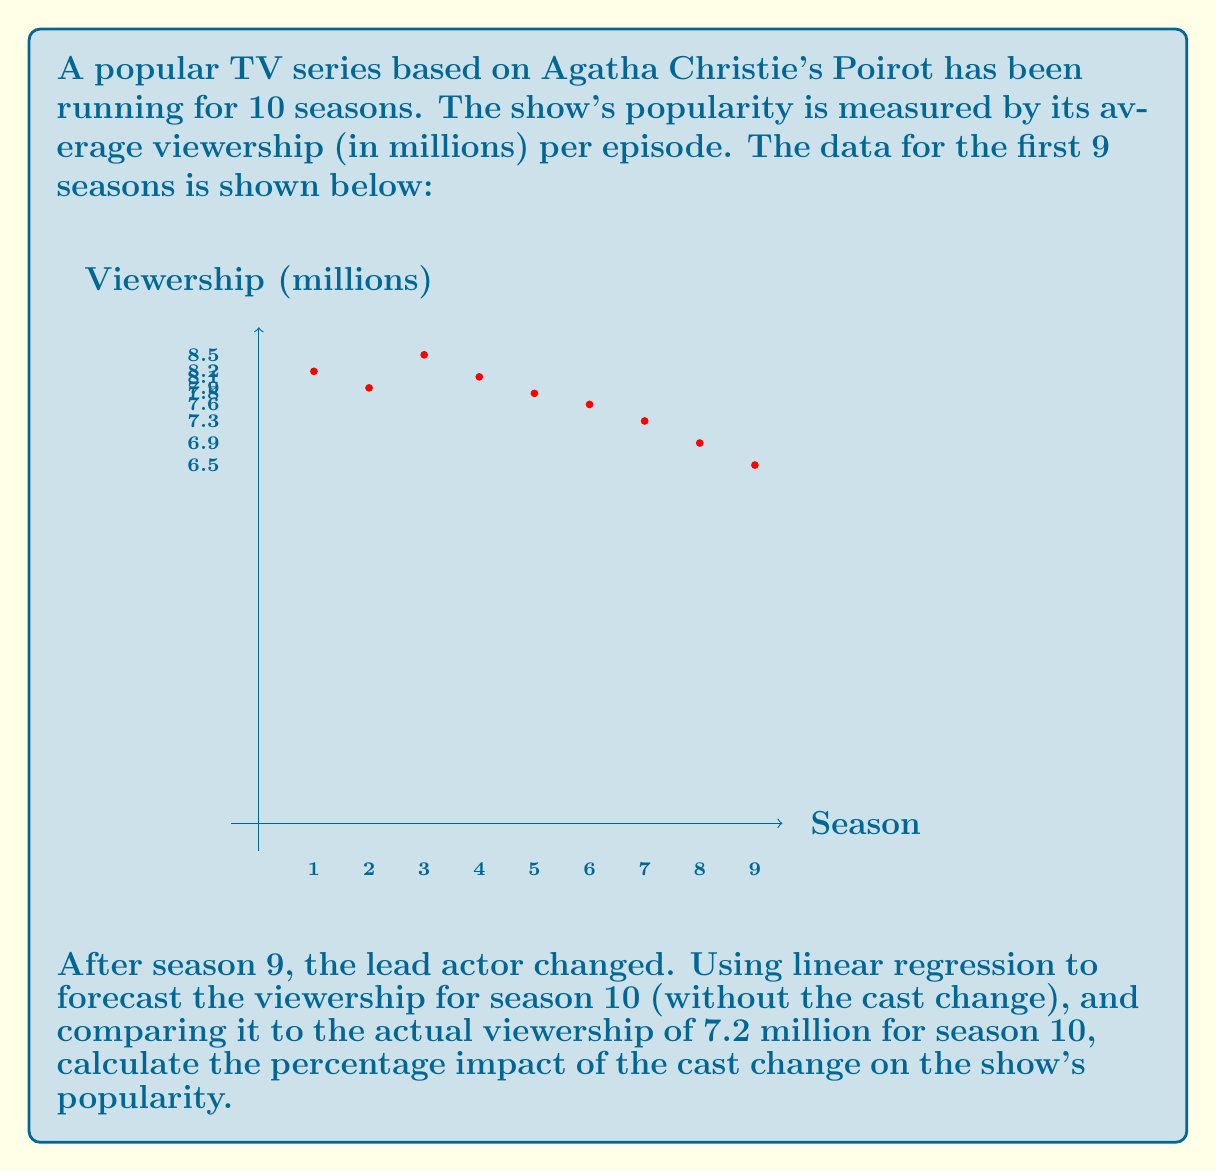Show me your answer to this math problem. To solve this problem, we'll follow these steps:

1. Perform linear regression on the first 9 seasons' data.
2. Use the regression equation to forecast season 10's viewership.
3. Compare the forecast with the actual viewership to calculate the impact.

Step 1: Linear Regression

Let $x$ represent the season number and $y$ represent the viewership.

Calculate the means:
$\bar{x} = \frac{1+2+3+4+5+6+7+8+9}{9} = 5$
$\bar{y} = \frac{8.2+7.9+8.5+8.1+7.8+7.6+7.3+6.9+6.5}{9} = 7.644$

Calculate $\sum (x_i - \bar{x})(y_i - \bar{y})$ and $\sum (x_i - \bar{x})^2$:

$\sum (x_i - \bar{x})(y_i - \bar{y}) = -6.06$
$\sum (x_i - \bar{x})^2 = 60$

The slope $b$ of the regression line is:
$b = \frac{\sum (x_i - \bar{x})(y_i - \bar{y})}{\sum (x_i - \bar{x})^2} = \frac{-6.06}{60} = -0.101$

The y-intercept $a$ is:
$a = \bar{y} - b\bar{x} = 7.644 - (-0.101 \times 5) = 8.149$

So, the regression equation is:
$y = 8.149 - 0.101x$

Step 2: Forecast Season 10

For $x = 10$ (season 10):
$y = 8.149 - 0.101 \times 10 = 7.139$ million viewers

Step 3: Calculate Impact

Actual viewership for season 10: 7.2 million
Forecasted viewership: 7.139 million

Difference: $7.2 - 7.139 = 0.061$ million

Percentage impact:
$\frac{0.061}{7.139} \times 100\% = 0.85\%$

The positive impact suggests that the cast change actually improved viewership slightly, contrary to the declining trend.
Answer: 0.85% increase 